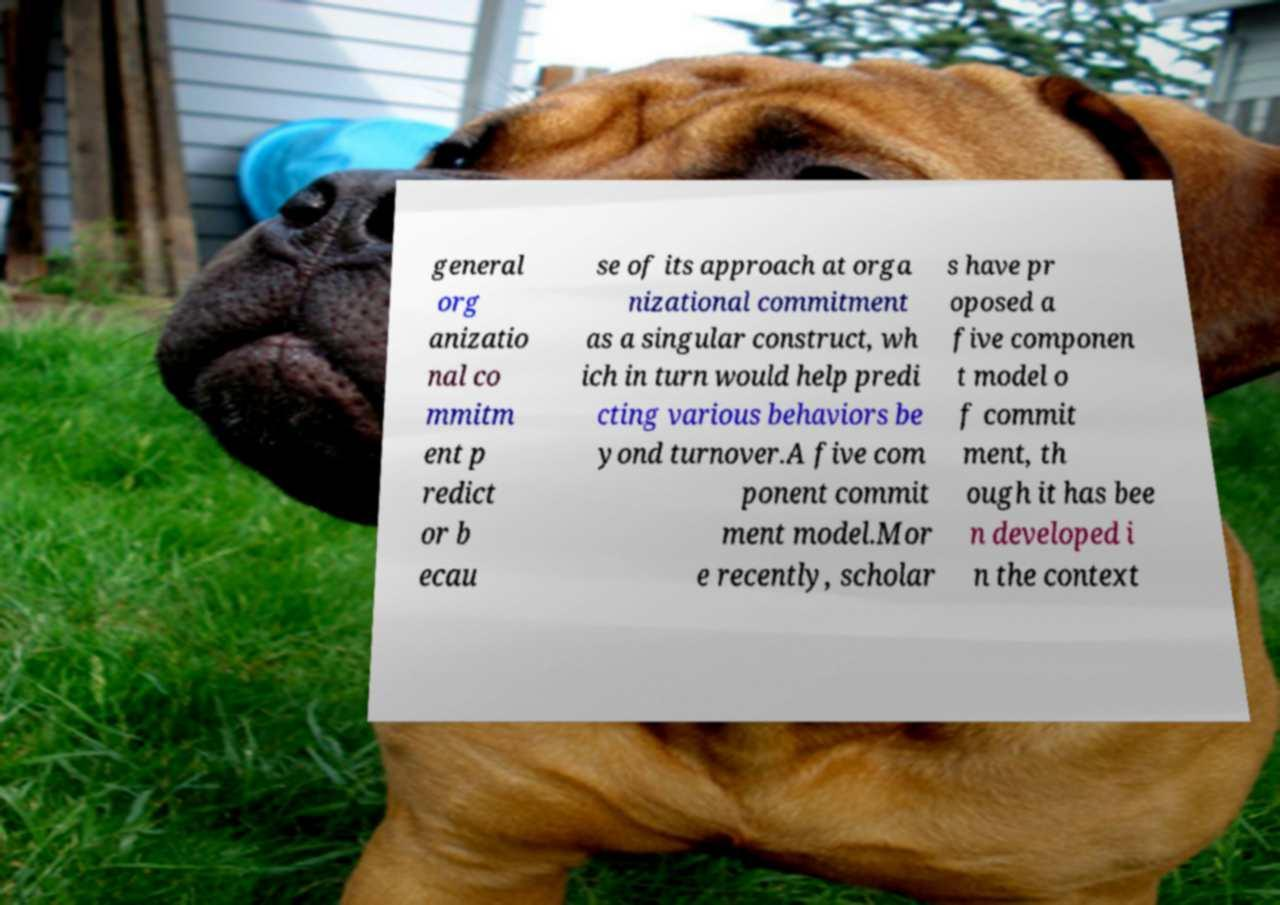There's text embedded in this image that I need extracted. Can you transcribe it verbatim? general org anizatio nal co mmitm ent p redict or b ecau se of its approach at orga nizational commitment as a singular construct, wh ich in turn would help predi cting various behaviors be yond turnover.A five com ponent commit ment model.Mor e recently, scholar s have pr oposed a five componen t model o f commit ment, th ough it has bee n developed i n the context 